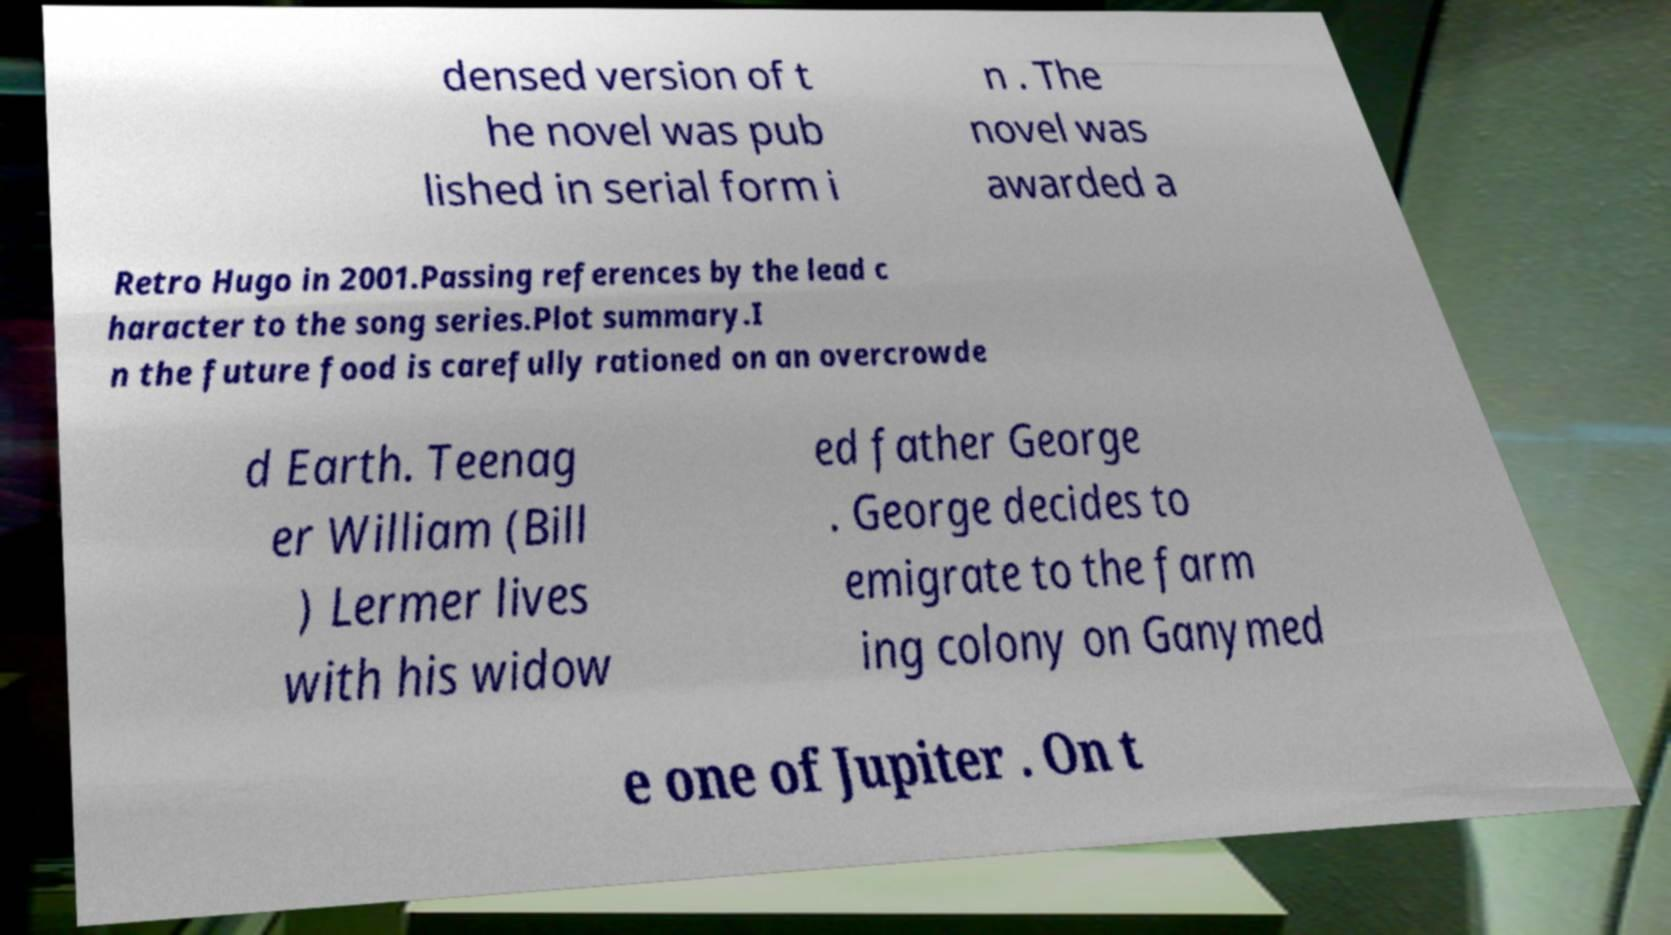Can you accurately transcribe the text from the provided image for me? densed version of t he novel was pub lished in serial form i n . The novel was awarded a Retro Hugo in 2001.Passing references by the lead c haracter to the song series.Plot summary.I n the future food is carefully rationed on an overcrowde d Earth. Teenag er William (Bill ) Lermer lives with his widow ed father George . George decides to emigrate to the farm ing colony on Ganymed e one of Jupiter . On t 